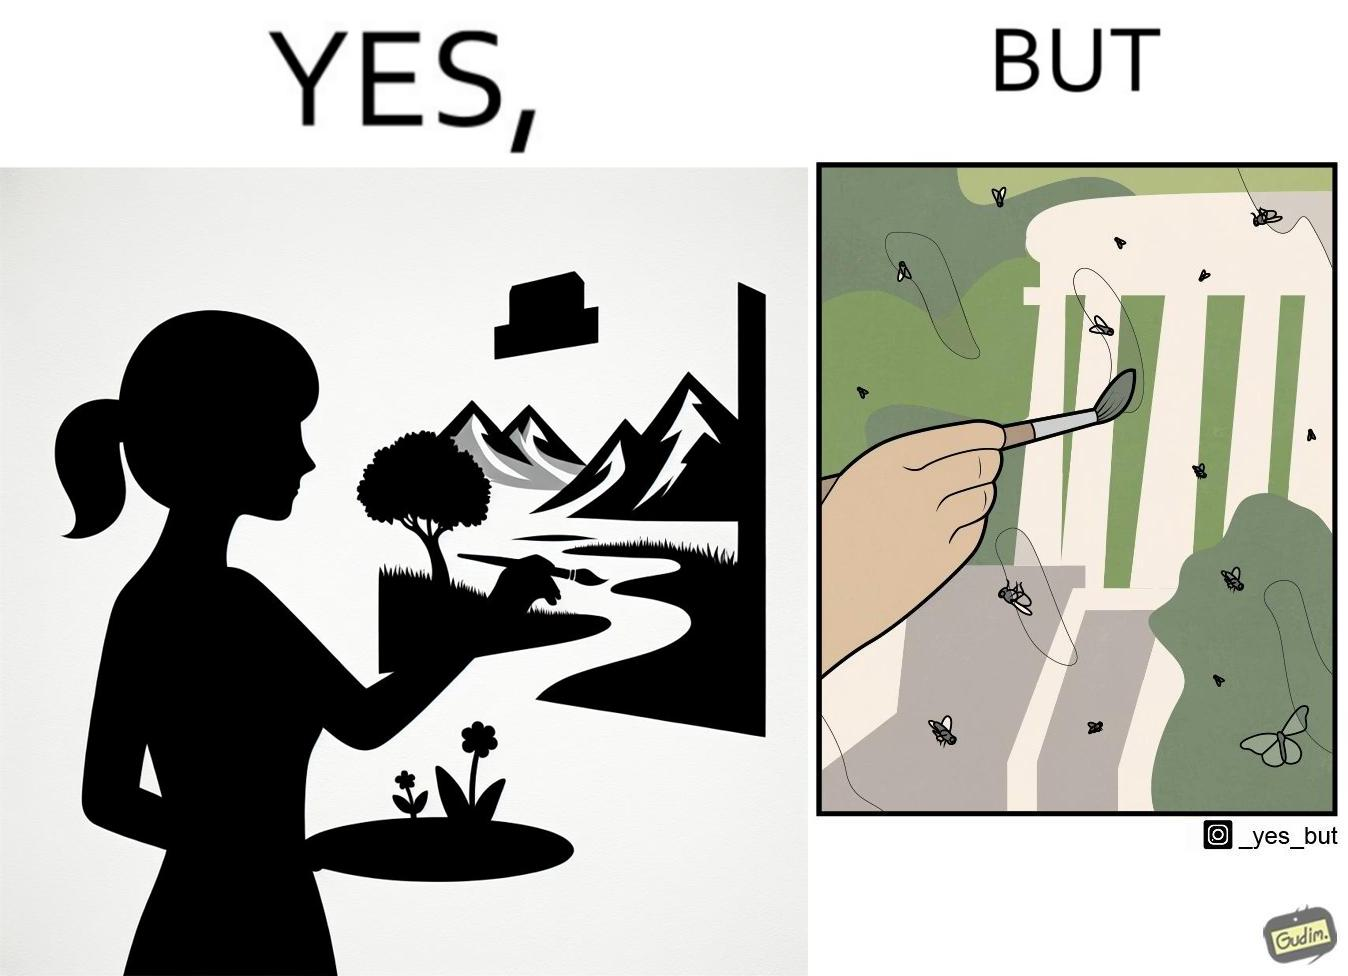Describe what you see in the left and right parts of this image. In the left part of the image: It is a woman painting a natural scenery In the right part of the image: A number of flies stuck on a painting 